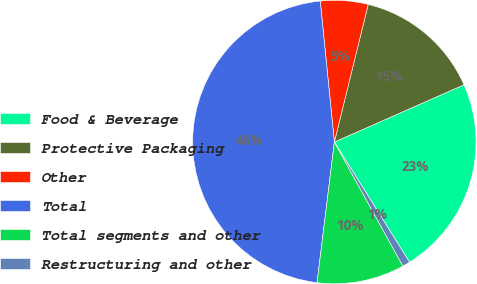Convert chart. <chart><loc_0><loc_0><loc_500><loc_500><pie_chart><fcel>Food & Beverage<fcel>Protective Packaging<fcel>Other<fcel>Total<fcel>Total segments and other<fcel>Restructuring and other<nl><fcel>22.72%<fcel>14.54%<fcel>5.43%<fcel>46.46%<fcel>9.98%<fcel>0.87%<nl></chart> 